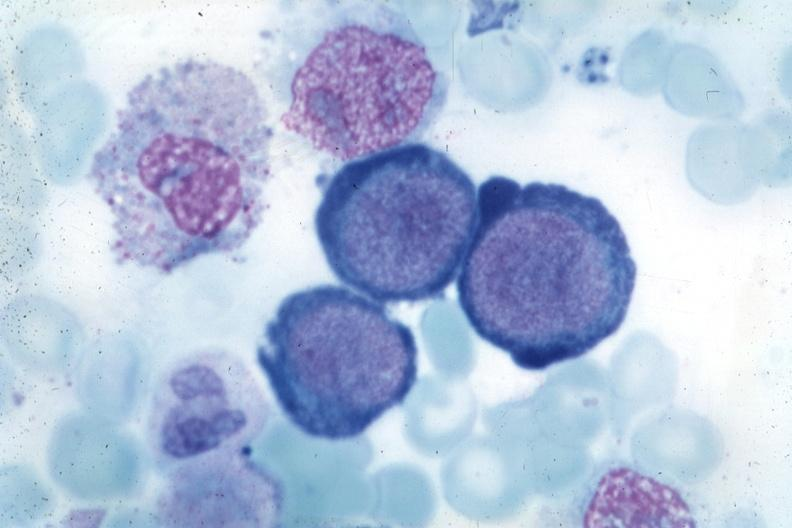s megaloblasts pernicious anemia present?
Answer the question using a single word or phrase. Yes 